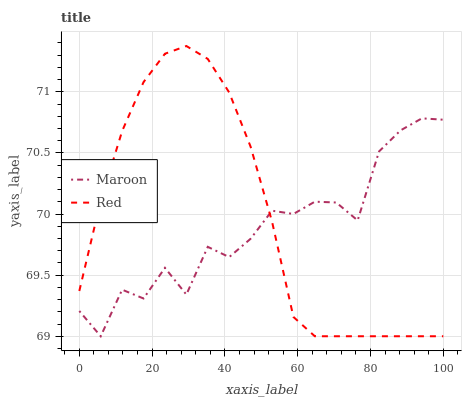Does Maroon have the minimum area under the curve?
Answer yes or no. Yes. Does Red have the maximum area under the curve?
Answer yes or no. Yes. Does Maroon have the maximum area under the curve?
Answer yes or no. No. Is Red the smoothest?
Answer yes or no. Yes. Is Maroon the roughest?
Answer yes or no. Yes. Is Maroon the smoothest?
Answer yes or no. No. Does Red have the highest value?
Answer yes or no. Yes. Does Maroon have the highest value?
Answer yes or no. No. Does Maroon intersect Red?
Answer yes or no. Yes. Is Maroon less than Red?
Answer yes or no. No. Is Maroon greater than Red?
Answer yes or no. No. 